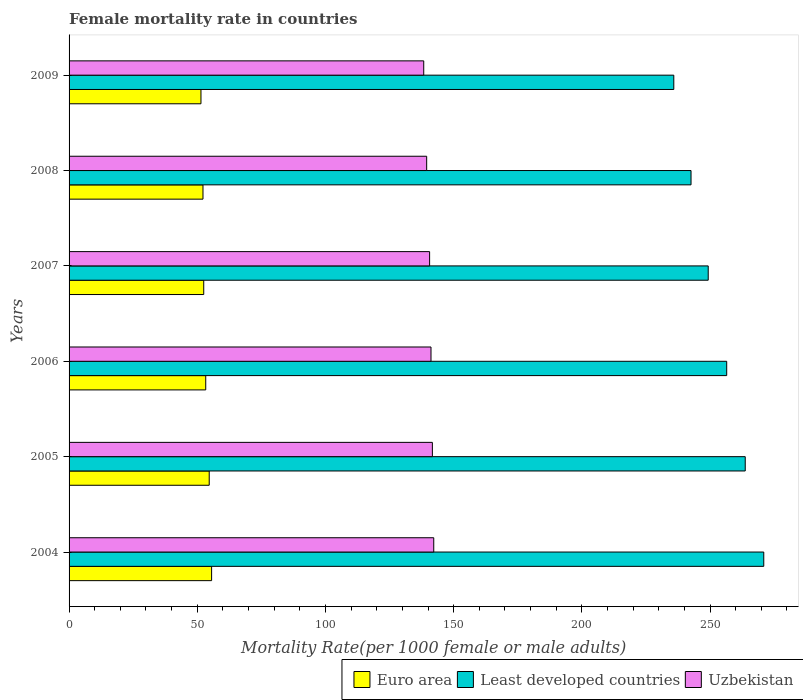How many groups of bars are there?
Ensure brevity in your answer.  6. How many bars are there on the 6th tick from the top?
Ensure brevity in your answer.  3. What is the label of the 4th group of bars from the top?
Your answer should be compact. 2006. In how many cases, is the number of bars for a given year not equal to the number of legend labels?
Offer a terse response. 0. What is the female mortality rate in Euro area in 2008?
Offer a terse response. 52.23. Across all years, what is the maximum female mortality rate in Euro area?
Offer a very short reply. 55.6. Across all years, what is the minimum female mortality rate in Uzbekistan?
Offer a very short reply. 138.34. In which year was the female mortality rate in Euro area maximum?
Offer a terse response. 2004. In which year was the female mortality rate in Least developed countries minimum?
Ensure brevity in your answer.  2009. What is the total female mortality rate in Uzbekistan in the graph?
Make the answer very short. 843.57. What is the difference between the female mortality rate in Uzbekistan in 2006 and that in 2007?
Your response must be concise. 0.54. What is the difference between the female mortality rate in Euro area in 2008 and the female mortality rate in Uzbekistan in 2007?
Offer a very short reply. -88.4. What is the average female mortality rate in Least developed countries per year?
Ensure brevity in your answer.  253.16. In the year 2005, what is the difference between the female mortality rate in Euro area and female mortality rate in Uzbekistan?
Offer a terse response. -87.04. In how many years, is the female mortality rate in Uzbekistan greater than 140 ?
Your answer should be compact. 4. What is the ratio of the female mortality rate in Uzbekistan in 2004 to that in 2008?
Ensure brevity in your answer.  1.02. What is the difference between the highest and the second highest female mortality rate in Uzbekistan?
Your answer should be compact. 0.54. What is the difference between the highest and the lowest female mortality rate in Uzbekistan?
Give a very brief answer. 3.91. Is the sum of the female mortality rate in Euro area in 2004 and 2006 greater than the maximum female mortality rate in Uzbekistan across all years?
Your answer should be very brief. No. What does the 2nd bar from the top in 2006 represents?
Offer a terse response. Least developed countries. What does the 3rd bar from the bottom in 2009 represents?
Make the answer very short. Uzbekistan. How many bars are there?
Ensure brevity in your answer.  18. Are all the bars in the graph horizontal?
Your answer should be very brief. Yes. Where does the legend appear in the graph?
Make the answer very short. Bottom right. What is the title of the graph?
Offer a terse response. Female mortality rate in countries. What is the label or title of the X-axis?
Your response must be concise. Mortality Rate(per 1000 female or male adults). What is the label or title of the Y-axis?
Your answer should be compact. Years. What is the Mortality Rate(per 1000 female or male adults) of Euro area in 2004?
Your answer should be very brief. 55.6. What is the Mortality Rate(per 1000 female or male adults) in Least developed countries in 2004?
Provide a short and direct response. 270.96. What is the Mortality Rate(per 1000 female or male adults) in Uzbekistan in 2004?
Your response must be concise. 142.24. What is the Mortality Rate(per 1000 female or male adults) in Euro area in 2005?
Provide a succinct answer. 54.67. What is the Mortality Rate(per 1000 female or male adults) of Least developed countries in 2005?
Keep it short and to the point. 263.74. What is the Mortality Rate(per 1000 female or male adults) of Uzbekistan in 2005?
Offer a very short reply. 141.71. What is the Mortality Rate(per 1000 female or male adults) of Euro area in 2006?
Ensure brevity in your answer.  53.3. What is the Mortality Rate(per 1000 female or male adults) of Least developed countries in 2006?
Offer a very short reply. 256.51. What is the Mortality Rate(per 1000 female or male adults) in Uzbekistan in 2006?
Provide a short and direct response. 141.17. What is the Mortality Rate(per 1000 female or male adults) in Euro area in 2007?
Provide a succinct answer. 52.53. What is the Mortality Rate(per 1000 female or male adults) of Least developed countries in 2007?
Offer a terse response. 249.3. What is the Mortality Rate(per 1000 female or male adults) of Uzbekistan in 2007?
Make the answer very short. 140.63. What is the Mortality Rate(per 1000 female or male adults) of Euro area in 2008?
Provide a short and direct response. 52.23. What is the Mortality Rate(per 1000 female or male adults) of Least developed countries in 2008?
Provide a succinct answer. 242.59. What is the Mortality Rate(per 1000 female or male adults) of Uzbekistan in 2008?
Keep it short and to the point. 139.48. What is the Mortality Rate(per 1000 female or male adults) in Euro area in 2009?
Offer a very short reply. 51.45. What is the Mortality Rate(per 1000 female or male adults) in Least developed countries in 2009?
Provide a succinct answer. 235.88. What is the Mortality Rate(per 1000 female or male adults) in Uzbekistan in 2009?
Provide a succinct answer. 138.34. Across all years, what is the maximum Mortality Rate(per 1000 female or male adults) in Euro area?
Your response must be concise. 55.6. Across all years, what is the maximum Mortality Rate(per 1000 female or male adults) in Least developed countries?
Your answer should be very brief. 270.96. Across all years, what is the maximum Mortality Rate(per 1000 female or male adults) of Uzbekistan?
Your response must be concise. 142.24. Across all years, what is the minimum Mortality Rate(per 1000 female or male adults) of Euro area?
Offer a terse response. 51.45. Across all years, what is the minimum Mortality Rate(per 1000 female or male adults) in Least developed countries?
Offer a terse response. 235.88. Across all years, what is the minimum Mortality Rate(per 1000 female or male adults) of Uzbekistan?
Offer a terse response. 138.34. What is the total Mortality Rate(per 1000 female or male adults) in Euro area in the graph?
Your response must be concise. 319.77. What is the total Mortality Rate(per 1000 female or male adults) in Least developed countries in the graph?
Make the answer very short. 1518.98. What is the total Mortality Rate(per 1000 female or male adults) in Uzbekistan in the graph?
Your response must be concise. 843.57. What is the difference between the Mortality Rate(per 1000 female or male adults) of Euro area in 2004 and that in 2005?
Provide a succinct answer. 0.93. What is the difference between the Mortality Rate(per 1000 female or male adults) of Least developed countries in 2004 and that in 2005?
Provide a short and direct response. 7.23. What is the difference between the Mortality Rate(per 1000 female or male adults) in Uzbekistan in 2004 and that in 2005?
Make the answer very short. 0.54. What is the difference between the Mortality Rate(per 1000 female or male adults) in Euro area in 2004 and that in 2006?
Your answer should be compact. 2.29. What is the difference between the Mortality Rate(per 1000 female or male adults) of Least developed countries in 2004 and that in 2006?
Provide a succinct answer. 14.45. What is the difference between the Mortality Rate(per 1000 female or male adults) of Uzbekistan in 2004 and that in 2006?
Your answer should be very brief. 1.08. What is the difference between the Mortality Rate(per 1000 female or male adults) of Euro area in 2004 and that in 2007?
Offer a terse response. 3.07. What is the difference between the Mortality Rate(per 1000 female or male adults) of Least developed countries in 2004 and that in 2007?
Your answer should be compact. 21.66. What is the difference between the Mortality Rate(per 1000 female or male adults) of Uzbekistan in 2004 and that in 2007?
Make the answer very short. 1.61. What is the difference between the Mortality Rate(per 1000 female or male adults) in Euro area in 2004 and that in 2008?
Your response must be concise. 3.37. What is the difference between the Mortality Rate(per 1000 female or male adults) of Least developed countries in 2004 and that in 2008?
Ensure brevity in your answer.  28.37. What is the difference between the Mortality Rate(per 1000 female or male adults) in Uzbekistan in 2004 and that in 2008?
Provide a succinct answer. 2.76. What is the difference between the Mortality Rate(per 1000 female or male adults) in Euro area in 2004 and that in 2009?
Ensure brevity in your answer.  4.15. What is the difference between the Mortality Rate(per 1000 female or male adults) in Least developed countries in 2004 and that in 2009?
Keep it short and to the point. 35.09. What is the difference between the Mortality Rate(per 1000 female or male adults) of Uzbekistan in 2004 and that in 2009?
Provide a short and direct response. 3.91. What is the difference between the Mortality Rate(per 1000 female or male adults) of Euro area in 2005 and that in 2006?
Your response must be concise. 1.36. What is the difference between the Mortality Rate(per 1000 female or male adults) in Least developed countries in 2005 and that in 2006?
Your answer should be very brief. 7.23. What is the difference between the Mortality Rate(per 1000 female or male adults) in Uzbekistan in 2005 and that in 2006?
Your answer should be compact. 0.54. What is the difference between the Mortality Rate(per 1000 female or male adults) of Euro area in 2005 and that in 2007?
Offer a terse response. 2.14. What is the difference between the Mortality Rate(per 1000 female or male adults) in Least developed countries in 2005 and that in 2007?
Offer a terse response. 14.43. What is the difference between the Mortality Rate(per 1000 female or male adults) in Uzbekistan in 2005 and that in 2007?
Your answer should be very brief. 1.08. What is the difference between the Mortality Rate(per 1000 female or male adults) of Euro area in 2005 and that in 2008?
Offer a very short reply. 2.44. What is the difference between the Mortality Rate(per 1000 female or male adults) in Least developed countries in 2005 and that in 2008?
Your answer should be compact. 21.14. What is the difference between the Mortality Rate(per 1000 female or male adults) of Uzbekistan in 2005 and that in 2008?
Your answer should be very brief. 2.22. What is the difference between the Mortality Rate(per 1000 female or male adults) of Euro area in 2005 and that in 2009?
Keep it short and to the point. 3.22. What is the difference between the Mortality Rate(per 1000 female or male adults) in Least developed countries in 2005 and that in 2009?
Offer a terse response. 27.86. What is the difference between the Mortality Rate(per 1000 female or male adults) in Uzbekistan in 2005 and that in 2009?
Ensure brevity in your answer.  3.37. What is the difference between the Mortality Rate(per 1000 female or male adults) of Euro area in 2006 and that in 2007?
Provide a succinct answer. 0.77. What is the difference between the Mortality Rate(per 1000 female or male adults) in Least developed countries in 2006 and that in 2007?
Offer a very short reply. 7.21. What is the difference between the Mortality Rate(per 1000 female or male adults) in Uzbekistan in 2006 and that in 2007?
Make the answer very short. 0.54. What is the difference between the Mortality Rate(per 1000 female or male adults) of Euro area in 2006 and that in 2008?
Ensure brevity in your answer.  1.07. What is the difference between the Mortality Rate(per 1000 female or male adults) in Least developed countries in 2006 and that in 2008?
Make the answer very short. 13.92. What is the difference between the Mortality Rate(per 1000 female or male adults) in Uzbekistan in 2006 and that in 2008?
Offer a terse response. 1.68. What is the difference between the Mortality Rate(per 1000 female or male adults) of Euro area in 2006 and that in 2009?
Ensure brevity in your answer.  1.85. What is the difference between the Mortality Rate(per 1000 female or male adults) of Least developed countries in 2006 and that in 2009?
Your answer should be compact. 20.63. What is the difference between the Mortality Rate(per 1000 female or male adults) in Uzbekistan in 2006 and that in 2009?
Provide a short and direct response. 2.83. What is the difference between the Mortality Rate(per 1000 female or male adults) of Euro area in 2007 and that in 2008?
Make the answer very short. 0.3. What is the difference between the Mortality Rate(per 1000 female or male adults) in Least developed countries in 2007 and that in 2008?
Make the answer very short. 6.71. What is the difference between the Mortality Rate(per 1000 female or male adults) in Uzbekistan in 2007 and that in 2008?
Your response must be concise. 1.15. What is the difference between the Mortality Rate(per 1000 female or male adults) in Euro area in 2007 and that in 2009?
Give a very brief answer. 1.08. What is the difference between the Mortality Rate(per 1000 female or male adults) in Least developed countries in 2007 and that in 2009?
Provide a short and direct response. 13.43. What is the difference between the Mortality Rate(per 1000 female or male adults) of Uzbekistan in 2007 and that in 2009?
Offer a terse response. 2.29. What is the difference between the Mortality Rate(per 1000 female or male adults) in Euro area in 2008 and that in 2009?
Keep it short and to the point. 0.78. What is the difference between the Mortality Rate(per 1000 female or male adults) of Least developed countries in 2008 and that in 2009?
Offer a terse response. 6.72. What is the difference between the Mortality Rate(per 1000 female or male adults) of Uzbekistan in 2008 and that in 2009?
Provide a short and direct response. 1.15. What is the difference between the Mortality Rate(per 1000 female or male adults) of Euro area in 2004 and the Mortality Rate(per 1000 female or male adults) of Least developed countries in 2005?
Provide a succinct answer. -208.14. What is the difference between the Mortality Rate(per 1000 female or male adults) in Euro area in 2004 and the Mortality Rate(per 1000 female or male adults) in Uzbekistan in 2005?
Give a very brief answer. -86.11. What is the difference between the Mortality Rate(per 1000 female or male adults) of Least developed countries in 2004 and the Mortality Rate(per 1000 female or male adults) of Uzbekistan in 2005?
Keep it short and to the point. 129.26. What is the difference between the Mortality Rate(per 1000 female or male adults) in Euro area in 2004 and the Mortality Rate(per 1000 female or male adults) in Least developed countries in 2006?
Ensure brevity in your answer.  -200.91. What is the difference between the Mortality Rate(per 1000 female or male adults) in Euro area in 2004 and the Mortality Rate(per 1000 female or male adults) in Uzbekistan in 2006?
Give a very brief answer. -85.57. What is the difference between the Mortality Rate(per 1000 female or male adults) of Least developed countries in 2004 and the Mortality Rate(per 1000 female or male adults) of Uzbekistan in 2006?
Ensure brevity in your answer.  129.79. What is the difference between the Mortality Rate(per 1000 female or male adults) of Euro area in 2004 and the Mortality Rate(per 1000 female or male adults) of Least developed countries in 2007?
Your answer should be compact. -193.71. What is the difference between the Mortality Rate(per 1000 female or male adults) of Euro area in 2004 and the Mortality Rate(per 1000 female or male adults) of Uzbekistan in 2007?
Your answer should be compact. -85.03. What is the difference between the Mortality Rate(per 1000 female or male adults) of Least developed countries in 2004 and the Mortality Rate(per 1000 female or male adults) of Uzbekistan in 2007?
Offer a terse response. 130.33. What is the difference between the Mortality Rate(per 1000 female or male adults) of Euro area in 2004 and the Mortality Rate(per 1000 female or male adults) of Least developed countries in 2008?
Make the answer very short. -187. What is the difference between the Mortality Rate(per 1000 female or male adults) in Euro area in 2004 and the Mortality Rate(per 1000 female or male adults) in Uzbekistan in 2008?
Give a very brief answer. -83.89. What is the difference between the Mortality Rate(per 1000 female or male adults) of Least developed countries in 2004 and the Mortality Rate(per 1000 female or male adults) of Uzbekistan in 2008?
Offer a very short reply. 131.48. What is the difference between the Mortality Rate(per 1000 female or male adults) in Euro area in 2004 and the Mortality Rate(per 1000 female or male adults) in Least developed countries in 2009?
Provide a succinct answer. -180.28. What is the difference between the Mortality Rate(per 1000 female or male adults) of Euro area in 2004 and the Mortality Rate(per 1000 female or male adults) of Uzbekistan in 2009?
Your answer should be very brief. -82.74. What is the difference between the Mortality Rate(per 1000 female or male adults) of Least developed countries in 2004 and the Mortality Rate(per 1000 female or male adults) of Uzbekistan in 2009?
Your response must be concise. 132.62. What is the difference between the Mortality Rate(per 1000 female or male adults) of Euro area in 2005 and the Mortality Rate(per 1000 female or male adults) of Least developed countries in 2006?
Offer a terse response. -201.84. What is the difference between the Mortality Rate(per 1000 female or male adults) of Euro area in 2005 and the Mortality Rate(per 1000 female or male adults) of Uzbekistan in 2006?
Your response must be concise. -86.5. What is the difference between the Mortality Rate(per 1000 female or male adults) of Least developed countries in 2005 and the Mortality Rate(per 1000 female or male adults) of Uzbekistan in 2006?
Keep it short and to the point. 122.57. What is the difference between the Mortality Rate(per 1000 female or male adults) of Euro area in 2005 and the Mortality Rate(per 1000 female or male adults) of Least developed countries in 2007?
Give a very brief answer. -194.64. What is the difference between the Mortality Rate(per 1000 female or male adults) of Euro area in 2005 and the Mortality Rate(per 1000 female or male adults) of Uzbekistan in 2007?
Your response must be concise. -85.96. What is the difference between the Mortality Rate(per 1000 female or male adults) in Least developed countries in 2005 and the Mortality Rate(per 1000 female or male adults) in Uzbekistan in 2007?
Provide a short and direct response. 123.11. What is the difference between the Mortality Rate(per 1000 female or male adults) in Euro area in 2005 and the Mortality Rate(per 1000 female or male adults) in Least developed countries in 2008?
Your answer should be very brief. -187.93. What is the difference between the Mortality Rate(per 1000 female or male adults) in Euro area in 2005 and the Mortality Rate(per 1000 female or male adults) in Uzbekistan in 2008?
Offer a terse response. -84.82. What is the difference between the Mortality Rate(per 1000 female or male adults) of Least developed countries in 2005 and the Mortality Rate(per 1000 female or male adults) of Uzbekistan in 2008?
Provide a short and direct response. 124.25. What is the difference between the Mortality Rate(per 1000 female or male adults) in Euro area in 2005 and the Mortality Rate(per 1000 female or male adults) in Least developed countries in 2009?
Your answer should be compact. -181.21. What is the difference between the Mortality Rate(per 1000 female or male adults) of Euro area in 2005 and the Mortality Rate(per 1000 female or male adults) of Uzbekistan in 2009?
Offer a terse response. -83.67. What is the difference between the Mortality Rate(per 1000 female or male adults) of Least developed countries in 2005 and the Mortality Rate(per 1000 female or male adults) of Uzbekistan in 2009?
Your answer should be very brief. 125.4. What is the difference between the Mortality Rate(per 1000 female or male adults) of Euro area in 2006 and the Mortality Rate(per 1000 female or male adults) of Least developed countries in 2007?
Your answer should be compact. -196. What is the difference between the Mortality Rate(per 1000 female or male adults) in Euro area in 2006 and the Mortality Rate(per 1000 female or male adults) in Uzbekistan in 2007?
Keep it short and to the point. -87.33. What is the difference between the Mortality Rate(per 1000 female or male adults) of Least developed countries in 2006 and the Mortality Rate(per 1000 female or male adults) of Uzbekistan in 2007?
Your response must be concise. 115.88. What is the difference between the Mortality Rate(per 1000 female or male adults) of Euro area in 2006 and the Mortality Rate(per 1000 female or male adults) of Least developed countries in 2008?
Provide a short and direct response. -189.29. What is the difference between the Mortality Rate(per 1000 female or male adults) of Euro area in 2006 and the Mortality Rate(per 1000 female or male adults) of Uzbekistan in 2008?
Your answer should be very brief. -86.18. What is the difference between the Mortality Rate(per 1000 female or male adults) of Least developed countries in 2006 and the Mortality Rate(per 1000 female or male adults) of Uzbekistan in 2008?
Offer a very short reply. 117.03. What is the difference between the Mortality Rate(per 1000 female or male adults) of Euro area in 2006 and the Mortality Rate(per 1000 female or male adults) of Least developed countries in 2009?
Keep it short and to the point. -182.57. What is the difference between the Mortality Rate(per 1000 female or male adults) of Euro area in 2006 and the Mortality Rate(per 1000 female or male adults) of Uzbekistan in 2009?
Ensure brevity in your answer.  -85.04. What is the difference between the Mortality Rate(per 1000 female or male adults) of Least developed countries in 2006 and the Mortality Rate(per 1000 female or male adults) of Uzbekistan in 2009?
Provide a short and direct response. 118.17. What is the difference between the Mortality Rate(per 1000 female or male adults) in Euro area in 2007 and the Mortality Rate(per 1000 female or male adults) in Least developed countries in 2008?
Make the answer very short. -190.06. What is the difference between the Mortality Rate(per 1000 female or male adults) of Euro area in 2007 and the Mortality Rate(per 1000 female or male adults) of Uzbekistan in 2008?
Offer a terse response. -86.96. What is the difference between the Mortality Rate(per 1000 female or male adults) of Least developed countries in 2007 and the Mortality Rate(per 1000 female or male adults) of Uzbekistan in 2008?
Your answer should be very brief. 109.82. What is the difference between the Mortality Rate(per 1000 female or male adults) of Euro area in 2007 and the Mortality Rate(per 1000 female or male adults) of Least developed countries in 2009?
Provide a short and direct response. -183.35. What is the difference between the Mortality Rate(per 1000 female or male adults) of Euro area in 2007 and the Mortality Rate(per 1000 female or male adults) of Uzbekistan in 2009?
Ensure brevity in your answer.  -85.81. What is the difference between the Mortality Rate(per 1000 female or male adults) in Least developed countries in 2007 and the Mortality Rate(per 1000 female or male adults) in Uzbekistan in 2009?
Keep it short and to the point. 110.96. What is the difference between the Mortality Rate(per 1000 female or male adults) of Euro area in 2008 and the Mortality Rate(per 1000 female or male adults) of Least developed countries in 2009?
Your response must be concise. -183.64. What is the difference between the Mortality Rate(per 1000 female or male adults) of Euro area in 2008 and the Mortality Rate(per 1000 female or male adults) of Uzbekistan in 2009?
Your response must be concise. -86.11. What is the difference between the Mortality Rate(per 1000 female or male adults) in Least developed countries in 2008 and the Mortality Rate(per 1000 female or male adults) in Uzbekistan in 2009?
Offer a terse response. 104.26. What is the average Mortality Rate(per 1000 female or male adults) of Euro area per year?
Make the answer very short. 53.3. What is the average Mortality Rate(per 1000 female or male adults) of Least developed countries per year?
Your response must be concise. 253.16. What is the average Mortality Rate(per 1000 female or male adults) in Uzbekistan per year?
Give a very brief answer. 140.59. In the year 2004, what is the difference between the Mortality Rate(per 1000 female or male adults) in Euro area and Mortality Rate(per 1000 female or male adults) in Least developed countries?
Your answer should be very brief. -215.37. In the year 2004, what is the difference between the Mortality Rate(per 1000 female or male adults) in Euro area and Mortality Rate(per 1000 female or male adults) in Uzbekistan?
Keep it short and to the point. -86.65. In the year 2004, what is the difference between the Mortality Rate(per 1000 female or male adults) in Least developed countries and Mortality Rate(per 1000 female or male adults) in Uzbekistan?
Your answer should be very brief. 128.72. In the year 2005, what is the difference between the Mortality Rate(per 1000 female or male adults) of Euro area and Mortality Rate(per 1000 female or male adults) of Least developed countries?
Ensure brevity in your answer.  -209.07. In the year 2005, what is the difference between the Mortality Rate(per 1000 female or male adults) in Euro area and Mortality Rate(per 1000 female or male adults) in Uzbekistan?
Offer a very short reply. -87.04. In the year 2005, what is the difference between the Mortality Rate(per 1000 female or male adults) of Least developed countries and Mortality Rate(per 1000 female or male adults) of Uzbekistan?
Give a very brief answer. 122.03. In the year 2006, what is the difference between the Mortality Rate(per 1000 female or male adults) in Euro area and Mortality Rate(per 1000 female or male adults) in Least developed countries?
Your answer should be very brief. -203.21. In the year 2006, what is the difference between the Mortality Rate(per 1000 female or male adults) in Euro area and Mortality Rate(per 1000 female or male adults) in Uzbekistan?
Provide a succinct answer. -87.87. In the year 2006, what is the difference between the Mortality Rate(per 1000 female or male adults) of Least developed countries and Mortality Rate(per 1000 female or male adults) of Uzbekistan?
Provide a succinct answer. 115.34. In the year 2007, what is the difference between the Mortality Rate(per 1000 female or male adults) of Euro area and Mortality Rate(per 1000 female or male adults) of Least developed countries?
Offer a terse response. -196.77. In the year 2007, what is the difference between the Mortality Rate(per 1000 female or male adults) of Euro area and Mortality Rate(per 1000 female or male adults) of Uzbekistan?
Make the answer very short. -88.1. In the year 2007, what is the difference between the Mortality Rate(per 1000 female or male adults) of Least developed countries and Mortality Rate(per 1000 female or male adults) of Uzbekistan?
Make the answer very short. 108.67. In the year 2008, what is the difference between the Mortality Rate(per 1000 female or male adults) in Euro area and Mortality Rate(per 1000 female or male adults) in Least developed countries?
Provide a short and direct response. -190.36. In the year 2008, what is the difference between the Mortality Rate(per 1000 female or male adults) of Euro area and Mortality Rate(per 1000 female or male adults) of Uzbekistan?
Make the answer very short. -87.25. In the year 2008, what is the difference between the Mortality Rate(per 1000 female or male adults) of Least developed countries and Mortality Rate(per 1000 female or male adults) of Uzbekistan?
Provide a succinct answer. 103.11. In the year 2009, what is the difference between the Mortality Rate(per 1000 female or male adults) in Euro area and Mortality Rate(per 1000 female or male adults) in Least developed countries?
Keep it short and to the point. -184.43. In the year 2009, what is the difference between the Mortality Rate(per 1000 female or male adults) in Euro area and Mortality Rate(per 1000 female or male adults) in Uzbekistan?
Keep it short and to the point. -86.89. In the year 2009, what is the difference between the Mortality Rate(per 1000 female or male adults) of Least developed countries and Mortality Rate(per 1000 female or male adults) of Uzbekistan?
Keep it short and to the point. 97.54. What is the ratio of the Mortality Rate(per 1000 female or male adults) in Euro area in 2004 to that in 2005?
Ensure brevity in your answer.  1.02. What is the ratio of the Mortality Rate(per 1000 female or male adults) of Least developed countries in 2004 to that in 2005?
Keep it short and to the point. 1.03. What is the ratio of the Mortality Rate(per 1000 female or male adults) of Euro area in 2004 to that in 2006?
Offer a terse response. 1.04. What is the ratio of the Mortality Rate(per 1000 female or male adults) in Least developed countries in 2004 to that in 2006?
Your answer should be compact. 1.06. What is the ratio of the Mortality Rate(per 1000 female or male adults) in Uzbekistan in 2004 to that in 2006?
Provide a short and direct response. 1.01. What is the ratio of the Mortality Rate(per 1000 female or male adults) in Euro area in 2004 to that in 2007?
Ensure brevity in your answer.  1.06. What is the ratio of the Mortality Rate(per 1000 female or male adults) in Least developed countries in 2004 to that in 2007?
Make the answer very short. 1.09. What is the ratio of the Mortality Rate(per 1000 female or male adults) in Uzbekistan in 2004 to that in 2007?
Your answer should be compact. 1.01. What is the ratio of the Mortality Rate(per 1000 female or male adults) of Euro area in 2004 to that in 2008?
Your answer should be compact. 1.06. What is the ratio of the Mortality Rate(per 1000 female or male adults) in Least developed countries in 2004 to that in 2008?
Offer a very short reply. 1.12. What is the ratio of the Mortality Rate(per 1000 female or male adults) of Uzbekistan in 2004 to that in 2008?
Your answer should be compact. 1.02. What is the ratio of the Mortality Rate(per 1000 female or male adults) in Euro area in 2004 to that in 2009?
Offer a very short reply. 1.08. What is the ratio of the Mortality Rate(per 1000 female or male adults) in Least developed countries in 2004 to that in 2009?
Your answer should be compact. 1.15. What is the ratio of the Mortality Rate(per 1000 female or male adults) of Uzbekistan in 2004 to that in 2009?
Your response must be concise. 1.03. What is the ratio of the Mortality Rate(per 1000 female or male adults) of Euro area in 2005 to that in 2006?
Offer a terse response. 1.03. What is the ratio of the Mortality Rate(per 1000 female or male adults) in Least developed countries in 2005 to that in 2006?
Ensure brevity in your answer.  1.03. What is the ratio of the Mortality Rate(per 1000 female or male adults) of Uzbekistan in 2005 to that in 2006?
Your response must be concise. 1. What is the ratio of the Mortality Rate(per 1000 female or male adults) of Euro area in 2005 to that in 2007?
Your response must be concise. 1.04. What is the ratio of the Mortality Rate(per 1000 female or male adults) in Least developed countries in 2005 to that in 2007?
Your answer should be compact. 1.06. What is the ratio of the Mortality Rate(per 1000 female or male adults) in Uzbekistan in 2005 to that in 2007?
Keep it short and to the point. 1.01. What is the ratio of the Mortality Rate(per 1000 female or male adults) in Euro area in 2005 to that in 2008?
Your response must be concise. 1.05. What is the ratio of the Mortality Rate(per 1000 female or male adults) of Least developed countries in 2005 to that in 2008?
Give a very brief answer. 1.09. What is the ratio of the Mortality Rate(per 1000 female or male adults) of Uzbekistan in 2005 to that in 2008?
Provide a short and direct response. 1.02. What is the ratio of the Mortality Rate(per 1000 female or male adults) of Euro area in 2005 to that in 2009?
Offer a terse response. 1.06. What is the ratio of the Mortality Rate(per 1000 female or male adults) in Least developed countries in 2005 to that in 2009?
Make the answer very short. 1.12. What is the ratio of the Mortality Rate(per 1000 female or male adults) of Uzbekistan in 2005 to that in 2009?
Offer a very short reply. 1.02. What is the ratio of the Mortality Rate(per 1000 female or male adults) in Euro area in 2006 to that in 2007?
Offer a very short reply. 1.01. What is the ratio of the Mortality Rate(per 1000 female or male adults) in Least developed countries in 2006 to that in 2007?
Ensure brevity in your answer.  1.03. What is the ratio of the Mortality Rate(per 1000 female or male adults) in Uzbekistan in 2006 to that in 2007?
Keep it short and to the point. 1. What is the ratio of the Mortality Rate(per 1000 female or male adults) of Euro area in 2006 to that in 2008?
Your answer should be compact. 1.02. What is the ratio of the Mortality Rate(per 1000 female or male adults) of Least developed countries in 2006 to that in 2008?
Your answer should be compact. 1.06. What is the ratio of the Mortality Rate(per 1000 female or male adults) in Uzbekistan in 2006 to that in 2008?
Give a very brief answer. 1.01. What is the ratio of the Mortality Rate(per 1000 female or male adults) of Euro area in 2006 to that in 2009?
Keep it short and to the point. 1.04. What is the ratio of the Mortality Rate(per 1000 female or male adults) of Least developed countries in 2006 to that in 2009?
Keep it short and to the point. 1.09. What is the ratio of the Mortality Rate(per 1000 female or male adults) of Uzbekistan in 2006 to that in 2009?
Offer a terse response. 1.02. What is the ratio of the Mortality Rate(per 1000 female or male adults) in Least developed countries in 2007 to that in 2008?
Provide a succinct answer. 1.03. What is the ratio of the Mortality Rate(per 1000 female or male adults) of Uzbekistan in 2007 to that in 2008?
Provide a short and direct response. 1.01. What is the ratio of the Mortality Rate(per 1000 female or male adults) in Euro area in 2007 to that in 2009?
Ensure brevity in your answer.  1.02. What is the ratio of the Mortality Rate(per 1000 female or male adults) in Least developed countries in 2007 to that in 2009?
Provide a short and direct response. 1.06. What is the ratio of the Mortality Rate(per 1000 female or male adults) in Uzbekistan in 2007 to that in 2009?
Ensure brevity in your answer.  1.02. What is the ratio of the Mortality Rate(per 1000 female or male adults) in Euro area in 2008 to that in 2009?
Your answer should be compact. 1.02. What is the ratio of the Mortality Rate(per 1000 female or male adults) in Least developed countries in 2008 to that in 2009?
Provide a short and direct response. 1.03. What is the ratio of the Mortality Rate(per 1000 female or male adults) in Uzbekistan in 2008 to that in 2009?
Your answer should be very brief. 1.01. What is the difference between the highest and the second highest Mortality Rate(per 1000 female or male adults) in Euro area?
Give a very brief answer. 0.93. What is the difference between the highest and the second highest Mortality Rate(per 1000 female or male adults) of Least developed countries?
Offer a terse response. 7.23. What is the difference between the highest and the second highest Mortality Rate(per 1000 female or male adults) of Uzbekistan?
Provide a succinct answer. 0.54. What is the difference between the highest and the lowest Mortality Rate(per 1000 female or male adults) of Euro area?
Your answer should be very brief. 4.15. What is the difference between the highest and the lowest Mortality Rate(per 1000 female or male adults) of Least developed countries?
Keep it short and to the point. 35.09. What is the difference between the highest and the lowest Mortality Rate(per 1000 female or male adults) of Uzbekistan?
Provide a short and direct response. 3.91. 